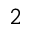<formula> <loc_0><loc_0><loc_500><loc_500>2</formula> 